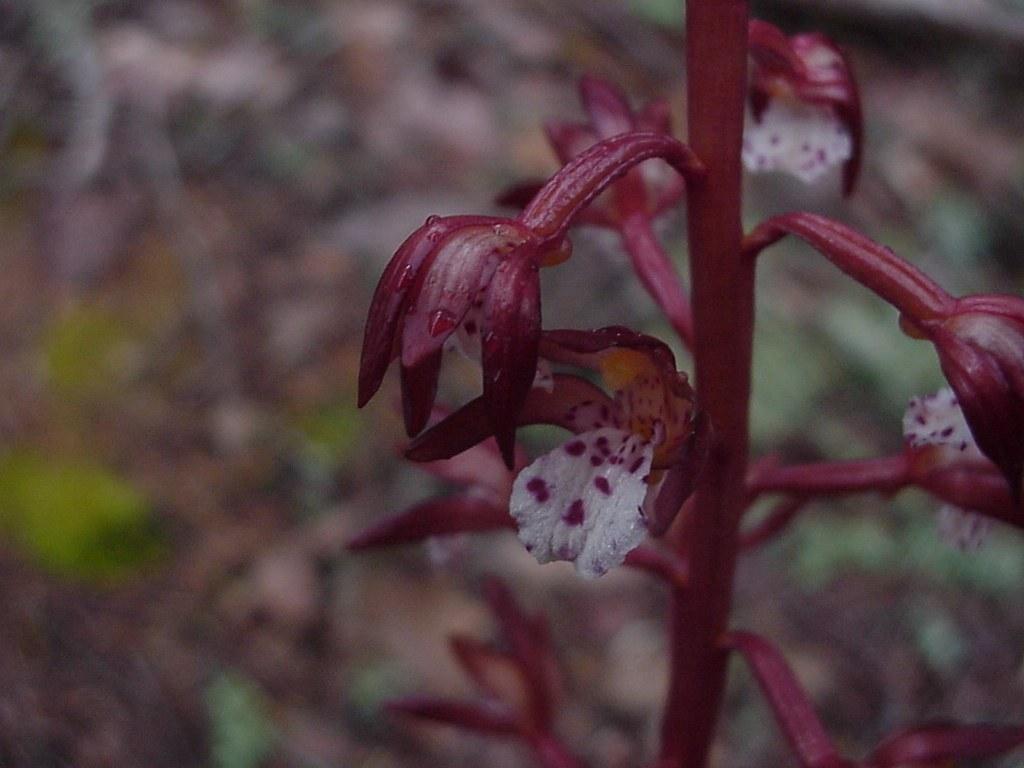Describe this image in one or two sentences. In this image we can see a stem with flowers. In the background it is blur. 